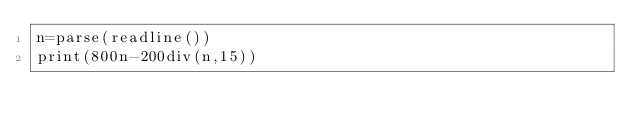Convert code to text. <code><loc_0><loc_0><loc_500><loc_500><_Julia_>n=parse(readline())
print(800n-200div(n,15))</code> 